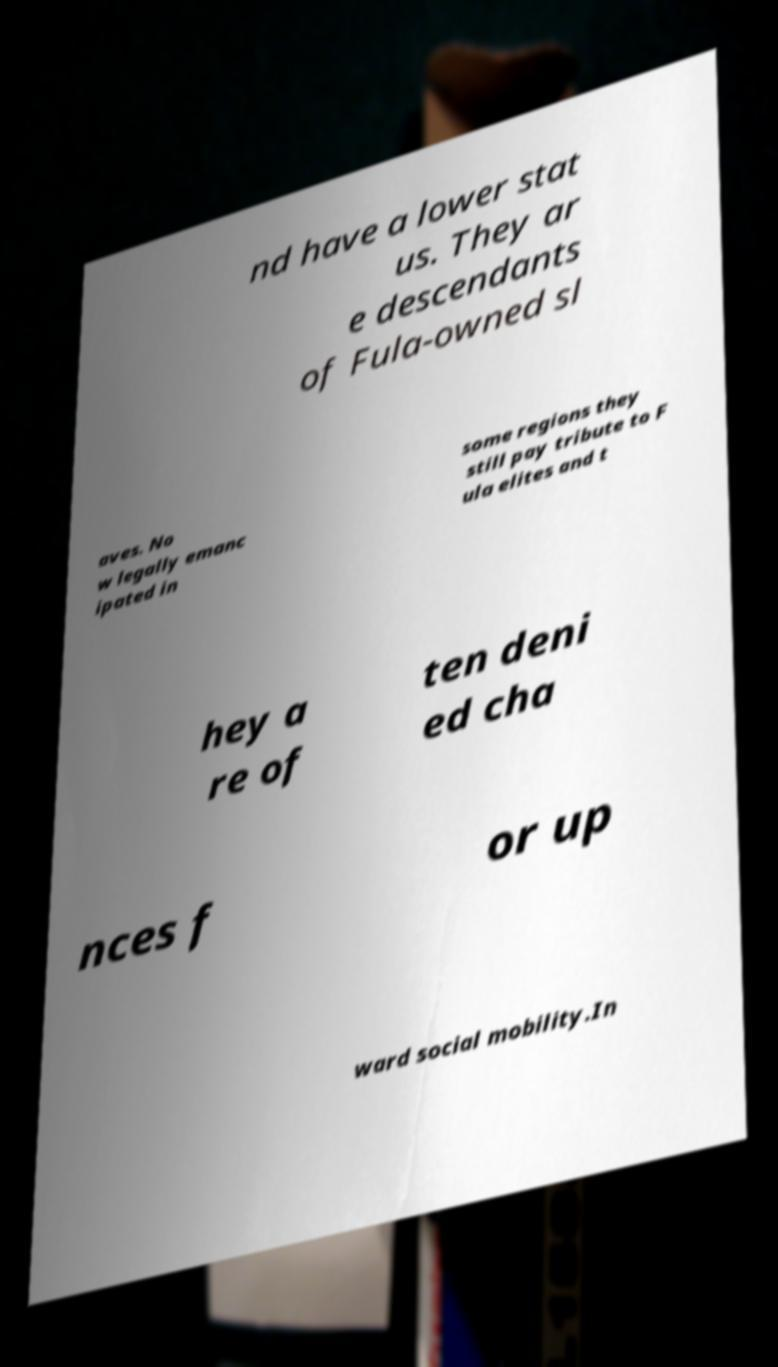Please read and relay the text visible in this image. What does it say? nd have a lower stat us. They ar e descendants of Fula-owned sl aves. No w legally emanc ipated in some regions they still pay tribute to F ula elites and t hey a re of ten deni ed cha nces f or up ward social mobility.In 